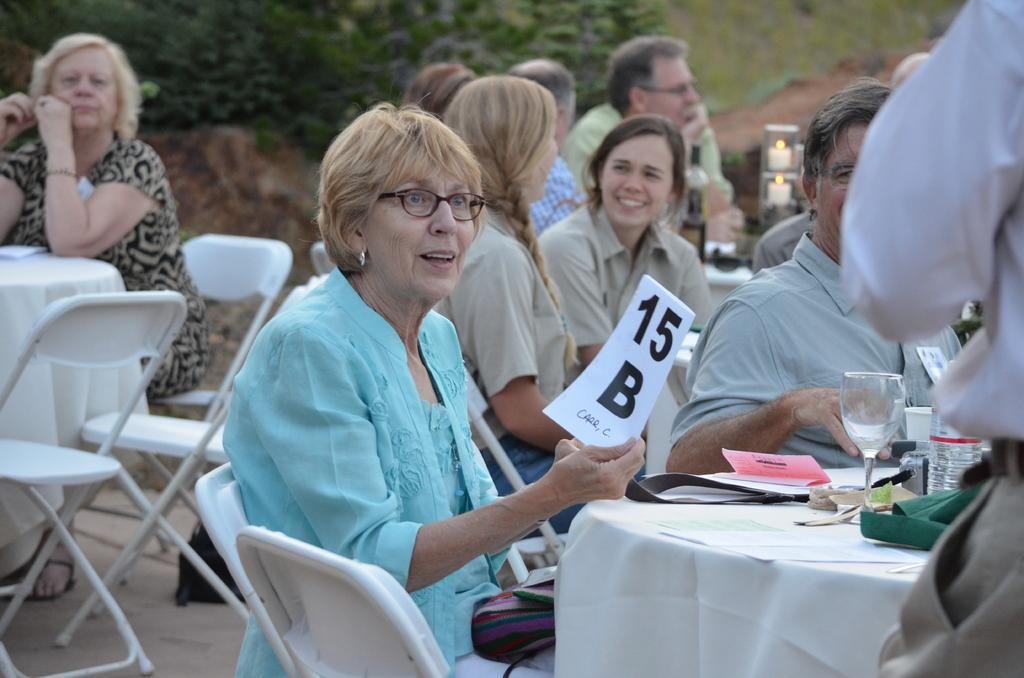Could you give a brief overview of what you see in this image? The women wearing a blue dress is holding a white paper in her right hand which has fifteen B written on it and there are few people sat in the background and there are also trees in the background. 